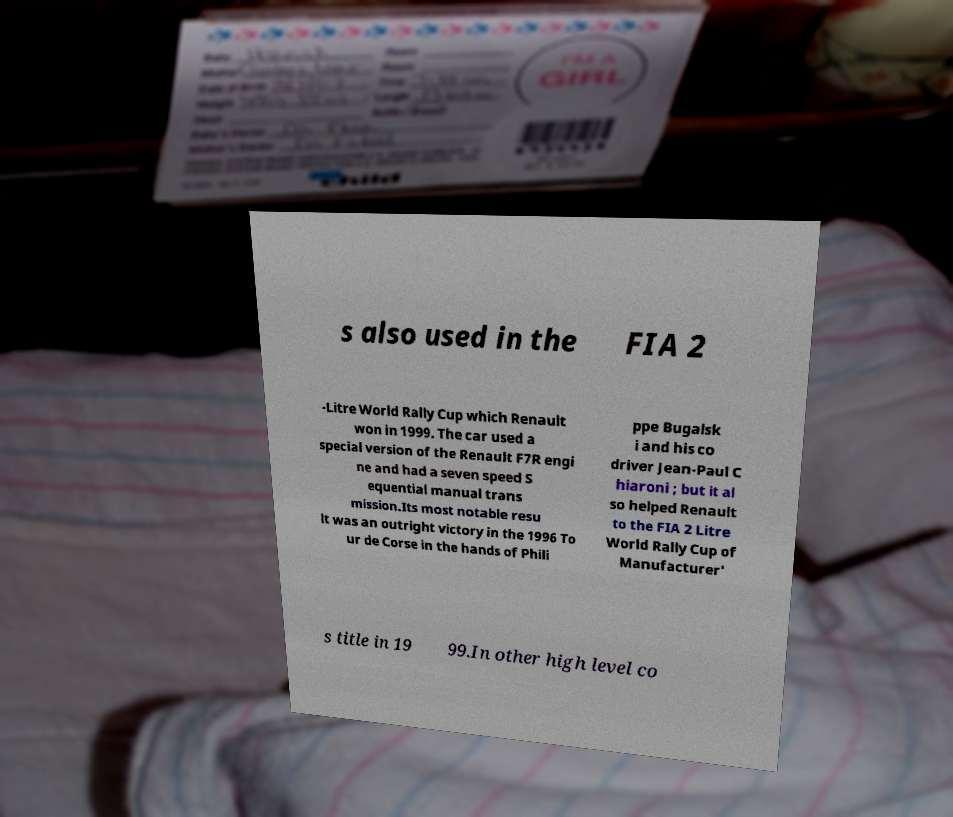What messages or text are displayed in this image? I need them in a readable, typed format. s also used in the FIA 2 -Litre World Rally Cup which Renault won in 1999. The car used a special version of the Renault F7R engi ne and had a seven speed S equential manual trans mission.Its most notable resu lt was an outright victory in the 1996 To ur de Corse in the hands of Phili ppe Bugalsk i and his co driver Jean-Paul C hiaroni ; but it al so helped Renault to the FIA 2 Litre World Rally Cup of Manufacturer' s title in 19 99.In other high level co 